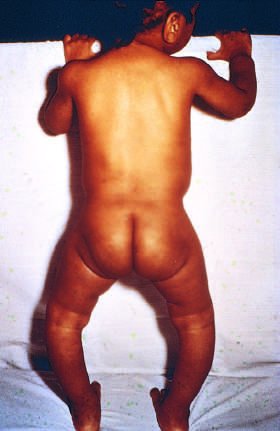how did note bowing of legs as a consequence of the formation of poorly mineralize bone in a child?
Answer the question using a single word or phrase. With rickets 